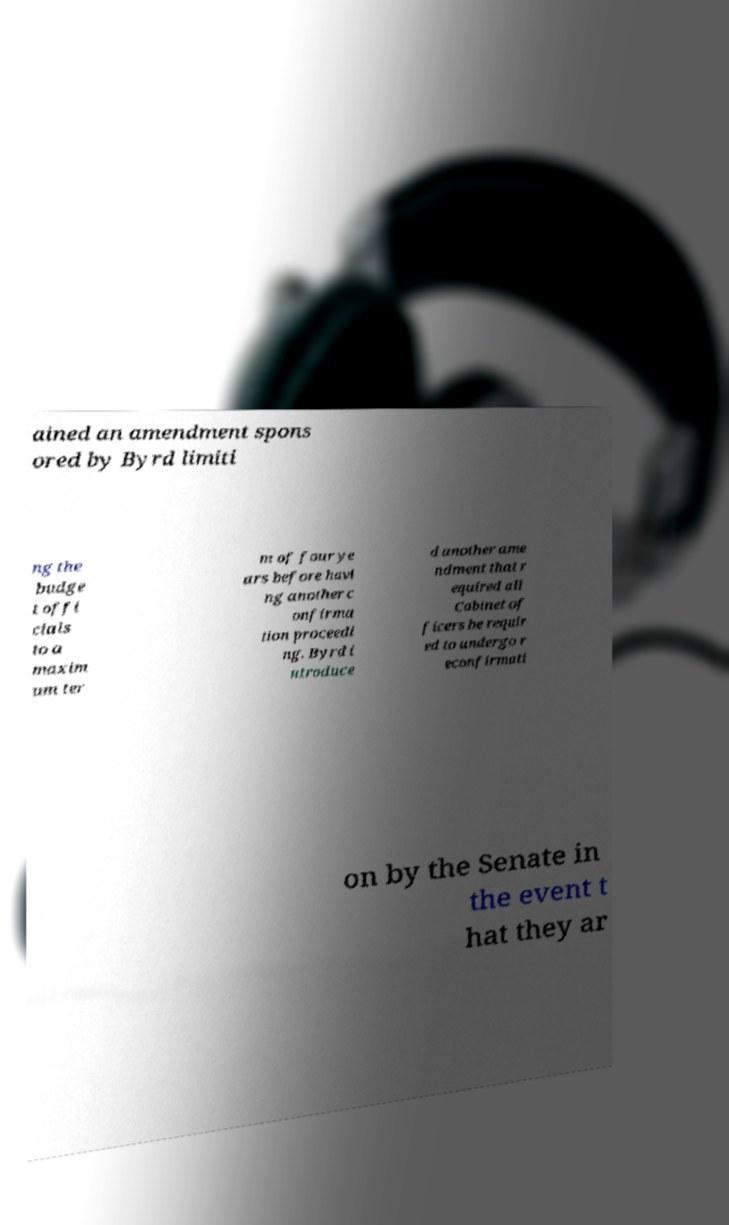Could you extract and type out the text from this image? ained an amendment spons ored by Byrd limiti ng the budge t offi cials to a maxim um ter m of four ye ars before havi ng another c onfirma tion proceedi ng. Byrd i ntroduce d another ame ndment that r equired all Cabinet of ficers be requir ed to undergo r econfirmati on by the Senate in the event t hat they ar 